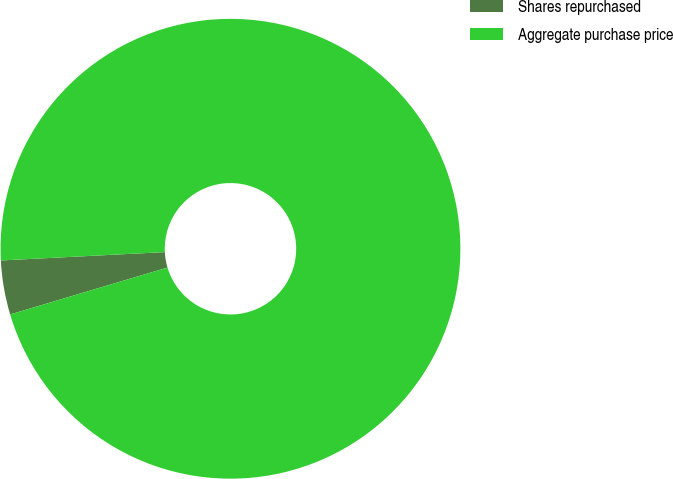Convert chart. <chart><loc_0><loc_0><loc_500><loc_500><pie_chart><fcel>Shares repurchased<fcel>Aggregate purchase price<nl><fcel>3.8%<fcel>96.2%<nl></chart> 